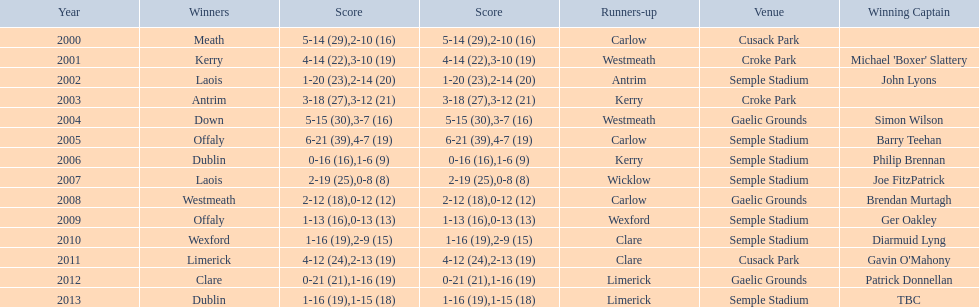Who was the winner after 2007? Laois. 